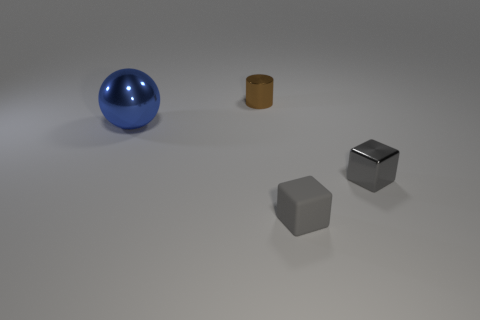What number of gray shiny cubes are to the left of the gray matte object?
Your response must be concise. 0. The gray metallic block is what size?
Make the answer very short. Small. Is the material of the small brown thing behind the blue sphere the same as the gray thing right of the gray rubber cube?
Your answer should be compact. Yes. Are there any big metallic spheres that have the same color as the tiny matte block?
Make the answer very short. No. The cylinder that is the same size as the rubber cube is what color?
Offer a very short reply. Brown. There is a tiny metallic thing that is in front of the blue sphere; does it have the same color as the large metallic sphere?
Your response must be concise. No. Is there a gray object made of the same material as the blue thing?
Keep it short and to the point. Yes. The metal thing that is the same color as the tiny matte block is what shape?
Give a very brief answer. Cube. Is the number of big balls that are behind the ball less than the number of large blue objects?
Keep it short and to the point. Yes. Is the size of the thing that is on the left side of the cylinder the same as the brown metallic cylinder?
Provide a succinct answer. No. 